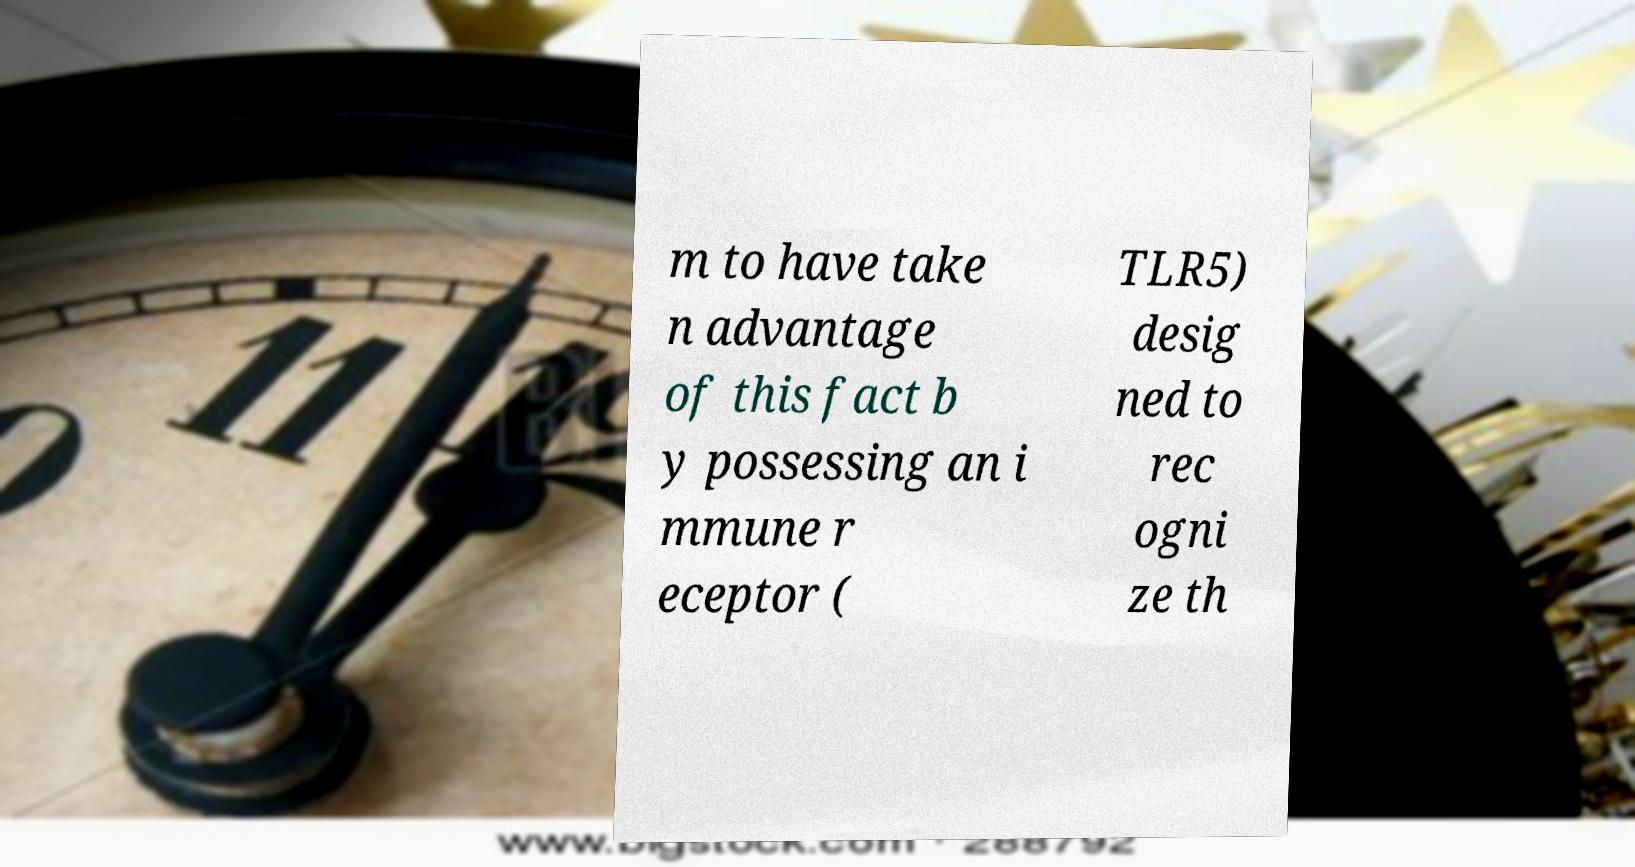Please read and relay the text visible in this image. What does it say? m to have take n advantage of this fact b y possessing an i mmune r eceptor ( TLR5) desig ned to rec ogni ze th 